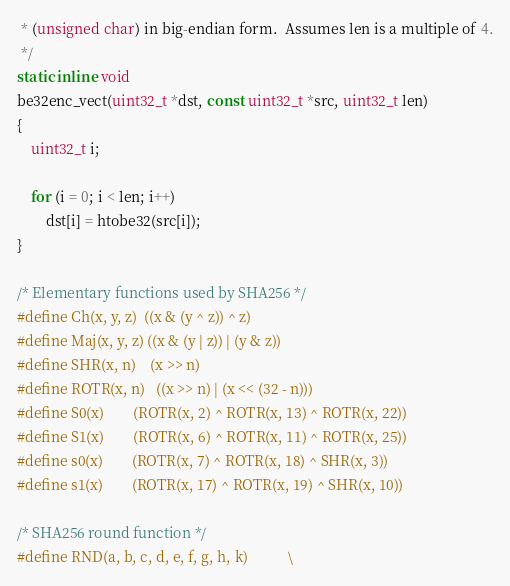Convert code to text. <code><loc_0><loc_0><loc_500><loc_500><_C_> * (unsigned char) in big-endian form.  Assumes len is a multiple of 4.
 */
static inline void
be32enc_vect(uint32_t *dst, const uint32_t *src, uint32_t len)
{
	uint32_t i;

	for (i = 0; i < len; i++)
		dst[i] = htobe32(src[i]);
}

/* Elementary functions used by SHA256 */
#define Ch(x, y, z)	((x & (y ^ z)) ^ z)
#define Maj(x, y, z)	((x & (y | z)) | (y & z))
#define SHR(x, n)	(x >> n)
#define ROTR(x, n)	((x >> n) | (x << (32 - n)))
#define S0(x)		(ROTR(x, 2) ^ ROTR(x, 13) ^ ROTR(x, 22))
#define S1(x)		(ROTR(x, 6) ^ ROTR(x, 11) ^ ROTR(x, 25))
#define s0(x)		(ROTR(x, 7) ^ ROTR(x, 18) ^ SHR(x, 3))
#define s1(x)		(ROTR(x, 17) ^ ROTR(x, 19) ^ SHR(x, 10))

/* SHA256 round function */
#define RND(a, b, c, d, e, f, g, h, k)			\</code> 